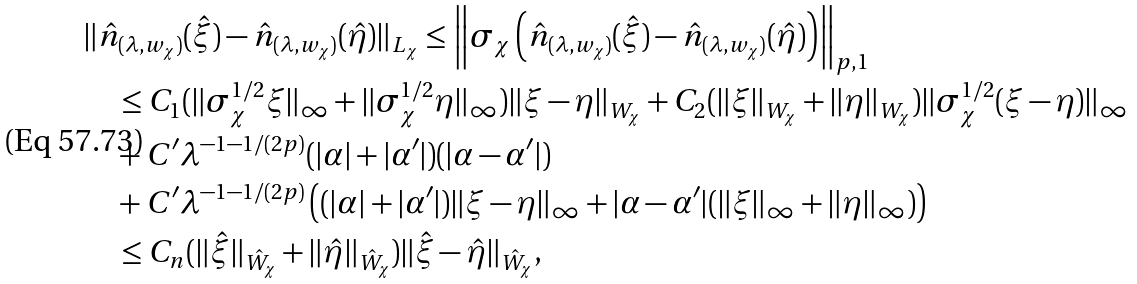Convert formula to latex. <formula><loc_0><loc_0><loc_500><loc_500>& \| \hat { n } _ { ( \lambda , w _ { \chi } ) } ( \hat { \xi } ) - \hat { n } _ { ( \lambda , w _ { \chi } ) } ( \hat { \eta } ) \| _ { L _ { \chi } } \leq \left \| \sigma _ { \chi } \left ( \hat { n } _ { ( \lambda , w _ { \chi } ) } ( \hat { \xi } ) - \hat { n } _ { ( \lambda , w _ { \chi } ) } ( \hat { \eta } ) \right ) \right \| _ { p , 1 } \\ & \quad \leq C _ { 1 } ( \| \sigma _ { \chi } ^ { 1 / 2 } \xi \| _ { \infty } + \| \sigma _ { \chi } ^ { 1 / 2 } \eta \| _ { \infty } ) \| \xi - \eta \| _ { W _ { \chi } } + C _ { 2 } ( \| \xi \| _ { W _ { \chi } } + \| \eta \| _ { W _ { \chi } } ) \| \sigma _ { \chi } ^ { 1 / 2 } ( \xi - \eta ) \| _ { \infty } \\ & \quad + C ^ { \prime } \lambda ^ { - 1 - 1 / ( 2 p ) } ( | \alpha | + | \alpha ^ { \prime } | ) ( | \alpha - \alpha ^ { \prime } | ) \\ & \quad + C ^ { \prime } \lambda ^ { - 1 - 1 / ( 2 p ) } \left ( ( | \alpha | + | \alpha ^ { \prime } | ) \| \xi - \eta \| _ { \infty } + | \alpha - \alpha ^ { \prime } | ( \| \xi \| _ { \infty } + \| \eta \| _ { \infty } ) \right ) \\ & \quad \leq C _ { n } ( \| \hat { \xi } \| _ { \hat { W } _ { \chi } } + \| \hat { \eta } \| _ { \hat { W } _ { \chi } } ) \| \hat { \xi } - \hat { \eta } \| _ { \hat { W } _ { \chi } } ,</formula> 